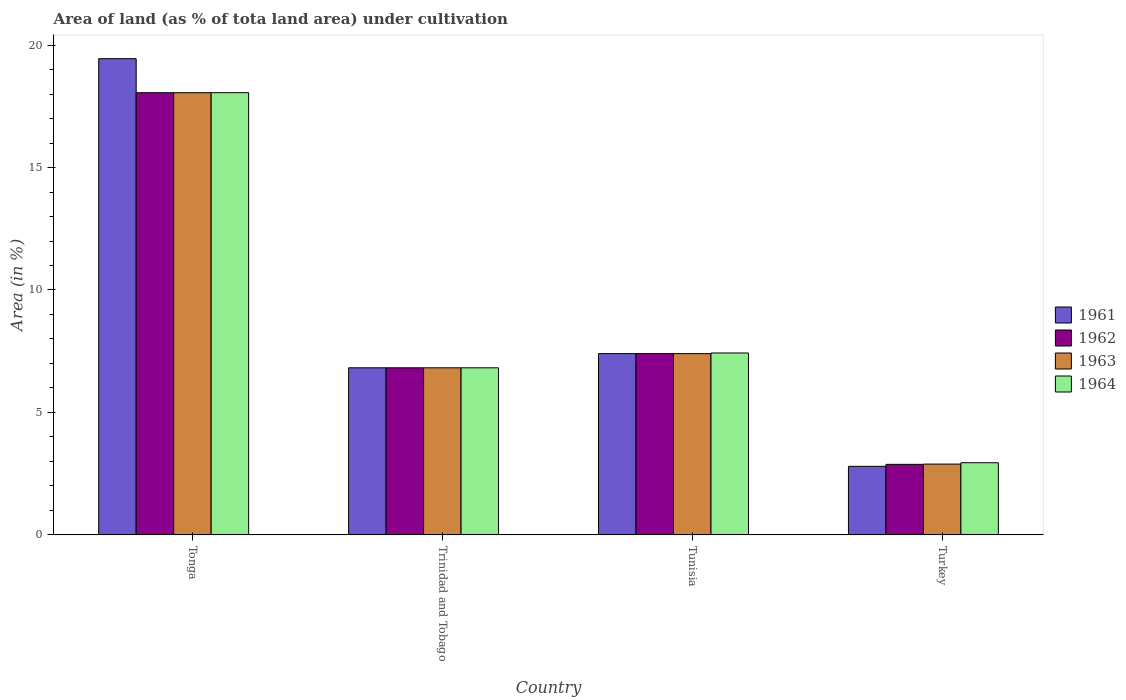Are the number of bars on each tick of the X-axis equal?
Your response must be concise. Yes. How many bars are there on the 3rd tick from the right?
Offer a very short reply. 4. What is the label of the 3rd group of bars from the left?
Provide a succinct answer. Tunisia. In how many cases, is the number of bars for a given country not equal to the number of legend labels?
Offer a very short reply. 0. What is the percentage of land under cultivation in 1961 in Tonga?
Offer a very short reply. 19.44. Across all countries, what is the maximum percentage of land under cultivation in 1962?
Provide a short and direct response. 18.06. Across all countries, what is the minimum percentage of land under cultivation in 1962?
Give a very brief answer. 2.88. In which country was the percentage of land under cultivation in 1964 maximum?
Your response must be concise. Tonga. In which country was the percentage of land under cultivation in 1964 minimum?
Make the answer very short. Turkey. What is the total percentage of land under cultivation in 1961 in the graph?
Your answer should be very brief. 36.47. What is the difference between the percentage of land under cultivation in 1961 in Tonga and that in Tunisia?
Your answer should be very brief. 12.04. What is the difference between the percentage of land under cultivation in 1963 in Trinidad and Tobago and the percentage of land under cultivation in 1964 in Turkey?
Keep it short and to the point. 3.88. What is the average percentage of land under cultivation in 1964 per country?
Keep it short and to the point. 8.81. What is the difference between the percentage of land under cultivation of/in 1963 and percentage of land under cultivation of/in 1961 in Tunisia?
Provide a succinct answer. 0. What is the ratio of the percentage of land under cultivation in 1963 in Tonga to that in Turkey?
Ensure brevity in your answer.  6.25. Is the percentage of land under cultivation in 1964 in Tunisia less than that in Turkey?
Provide a short and direct response. No. Is the difference between the percentage of land under cultivation in 1963 in Tonga and Trinidad and Tobago greater than the difference between the percentage of land under cultivation in 1961 in Tonga and Trinidad and Tobago?
Your answer should be very brief. No. What is the difference between the highest and the second highest percentage of land under cultivation in 1962?
Your answer should be very brief. 11.23. What is the difference between the highest and the lowest percentage of land under cultivation in 1961?
Offer a terse response. 16.65. Is the sum of the percentage of land under cultivation in 1963 in Trinidad and Tobago and Turkey greater than the maximum percentage of land under cultivation in 1962 across all countries?
Provide a succinct answer. No. Is it the case that in every country, the sum of the percentage of land under cultivation in 1962 and percentage of land under cultivation in 1963 is greater than the sum of percentage of land under cultivation in 1961 and percentage of land under cultivation in 1964?
Offer a terse response. No. What does the 1st bar from the left in Trinidad and Tobago represents?
Offer a very short reply. 1961. What does the 1st bar from the right in Turkey represents?
Offer a very short reply. 1964. What is the difference between two consecutive major ticks on the Y-axis?
Your response must be concise. 5. Are the values on the major ticks of Y-axis written in scientific E-notation?
Make the answer very short. No. How are the legend labels stacked?
Offer a very short reply. Vertical. What is the title of the graph?
Your response must be concise. Area of land (as % of tota land area) under cultivation. What is the label or title of the Y-axis?
Ensure brevity in your answer.  Area (in %). What is the Area (in %) in 1961 in Tonga?
Offer a terse response. 19.44. What is the Area (in %) of 1962 in Tonga?
Ensure brevity in your answer.  18.06. What is the Area (in %) in 1963 in Tonga?
Keep it short and to the point. 18.06. What is the Area (in %) of 1964 in Tonga?
Keep it short and to the point. 18.06. What is the Area (in %) of 1961 in Trinidad and Tobago?
Provide a short and direct response. 6.82. What is the Area (in %) of 1962 in Trinidad and Tobago?
Your answer should be compact. 6.82. What is the Area (in %) of 1963 in Trinidad and Tobago?
Your answer should be compact. 6.82. What is the Area (in %) in 1964 in Trinidad and Tobago?
Offer a very short reply. 6.82. What is the Area (in %) in 1961 in Tunisia?
Your answer should be very brief. 7.4. What is the Area (in %) in 1962 in Tunisia?
Your answer should be compact. 7.4. What is the Area (in %) in 1963 in Tunisia?
Make the answer very short. 7.4. What is the Area (in %) of 1964 in Tunisia?
Offer a terse response. 7.43. What is the Area (in %) in 1961 in Turkey?
Your answer should be compact. 2.8. What is the Area (in %) of 1962 in Turkey?
Keep it short and to the point. 2.88. What is the Area (in %) in 1963 in Turkey?
Provide a succinct answer. 2.89. What is the Area (in %) of 1964 in Turkey?
Offer a very short reply. 2.95. Across all countries, what is the maximum Area (in %) of 1961?
Give a very brief answer. 19.44. Across all countries, what is the maximum Area (in %) in 1962?
Your response must be concise. 18.06. Across all countries, what is the maximum Area (in %) in 1963?
Make the answer very short. 18.06. Across all countries, what is the maximum Area (in %) of 1964?
Give a very brief answer. 18.06. Across all countries, what is the minimum Area (in %) in 1961?
Offer a terse response. 2.8. Across all countries, what is the minimum Area (in %) in 1962?
Your response must be concise. 2.88. Across all countries, what is the minimum Area (in %) in 1963?
Give a very brief answer. 2.89. Across all countries, what is the minimum Area (in %) in 1964?
Your answer should be very brief. 2.95. What is the total Area (in %) of 1961 in the graph?
Offer a very short reply. 36.47. What is the total Area (in %) of 1962 in the graph?
Ensure brevity in your answer.  35.16. What is the total Area (in %) of 1963 in the graph?
Give a very brief answer. 35.17. What is the total Area (in %) in 1964 in the graph?
Your answer should be compact. 35.25. What is the difference between the Area (in %) in 1961 in Tonga and that in Trinidad and Tobago?
Your answer should be compact. 12.62. What is the difference between the Area (in %) in 1962 in Tonga and that in Trinidad and Tobago?
Provide a short and direct response. 11.23. What is the difference between the Area (in %) of 1963 in Tonga and that in Trinidad and Tobago?
Offer a very short reply. 11.23. What is the difference between the Area (in %) in 1964 in Tonga and that in Trinidad and Tobago?
Provide a succinct answer. 11.23. What is the difference between the Area (in %) in 1961 in Tonga and that in Tunisia?
Ensure brevity in your answer.  12.04. What is the difference between the Area (in %) of 1962 in Tonga and that in Tunisia?
Keep it short and to the point. 10.65. What is the difference between the Area (in %) of 1963 in Tonga and that in Tunisia?
Make the answer very short. 10.65. What is the difference between the Area (in %) in 1964 in Tonga and that in Tunisia?
Your answer should be very brief. 10.63. What is the difference between the Area (in %) of 1961 in Tonga and that in Turkey?
Offer a very short reply. 16.65. What is the difference between the Area (in %) in 1962 in Tonga and that in Turkey?
Your answer should be compact. 15.18. What is the difference between the Area (in %) of 1963 in Tonga and that in Turkey?
Give a very brief answer. 15.16. What is the difference between the Area (in %) of 1964 in Tonga and that in Turkey?
Your answer should be very brief. 15.11. What is the difference between the Area (in %) of 1961 in Trinidad and Tobago and that in Tunisia?
Your answer should be very brief. -0.58. What is the difference between the Area (in %) of 1962 in Trinidad and Tobago and that in Tunisia?
Ensure brevity in your answer.  -0.58. What is the difference between the Area (in %) in 1963 in Trinidad and Tobago and that in Tunisia?
Your answer should be compact. -0.58. What is the difference between the Area (in %) in 1964 in Trinidad and Tobago and that in Tunisia?
Ensure brevity in your answer.  -0.61. What is the difference between the Area (in %) of 1961 in Trinidad and Tobago and that in Turkey?
Give a very brief answer. 4.02. What is the difference between the Area (in %) of 1962 in Trinidad and Tobago and that in Turkey?
Provide a short and direct response. 3.94. What is the difference between the Area (in %) in 1963 in Trinidad and Tobago and that in Turkey?
Give a very brief answer. 3.93. What is the difference between the Area (in %) in 1964 in Trinidad and Tobago and that in Turkey?
Ensure brevity in your answer.  3.88. What is the difference between the Area (in %) in 1961 in Tunisia and that in Turkey?
Provide a succinct answer. 4.6. What is the difference between the Area (in %) in 1962 in Tunisia and that in Turkey?
Keep it short and to the point. 4.52. What is the difference between the Area (in %) in 1963 in Tunisia and that in Turkey?
Your answer should be very brief. 4.51. What is the difference between the Area (in %) of 1964 in Tunisia and that in Turkey?
Provide a short and direct response. 4.48. What is the difference between the Area (in %) of 1961 in Tonga and the Area (in %) of 1962 in Trinidad and Tobago?
Offer a terse response. 12.62. What is the difference between the Area (in %) of 1961 in Tonga and the Area (in %) of 1963 in Trinidad and Tobago?
Offer a terse response. 12.62. What is the difference between the Area (in %) in 1961 in Tonga and the Area (in %) in 1964 in Trinidad and Tobago?
Keep it short and to the point. 12.62. What is the difference between the Area (in %) in 1962 in Tonga and the Area (in %) in 1963 in Trinidad and Tobago?
Your answer should be very brief. 11.23. What is the difference between the Area (in %) in 1962 in Tonga and the Area (in %) in 1964 in Trinidad and Tobago?
Provide a short and direct response. 11.23. What is the difference between the Area (in %) in 1963 in Tonga and the Area (in %) in 1964 in Trinidad and Tobago?
Your answer should be very brief. 11.23. What is the difference between the Area (in %) in 1961 in Tonga and the Area (in %) in 1962 in Tunisia?
Offer a terse response. 12.04. What is the difference between the Area (in %) in 1961 in Tonga and the Area (in %) in 1963 in Tunisia?
Make the answer very short. 12.04. What is the difference between the Area (in %) of 1961 in Tonga and the Area (in %) of 1964 in Tunisia?
Provide a short and direct response. 12.02. What is the difference between the Area (in %) in 1962 in Tonga and the Area (in %) in 1963 in Tunisia?
Offer a very short reply. 10.65. What is the difference between the Area (in %) in 1962 in Tonga and the Area (in %) in 1964 in Tunisia?
Make the answer very short. 10.63. What is the difference between the Area (in %) in 1963 in Tonga and the Area (in %) in 1964 in Tunisia?
Give a very brief answer. 10.63. What is the difference between the Area (in %) in 1961 in Tonga and the Area (in %) in 1962 in Turkey?
Your answer should be very brief. 16.56. What is the difference between the Area (in %) of 1961 in Tonga and the Area (in %) of 1963 in Turkey?
Ensure brevity in your answer.  16.55. What is the difference between the Area (in %) in 1961 in Tonga and the Area (in %) in 1964 in Turkey?
Provide a succinct answer. 16.5. What is the difference between the Area (in %) in 1962 in Tonga and the Area (in %) in 1963 in Turkey?
Your answer should be compact. 15.16. What is the difference between the Area (in %) in 1962 in Tonga and the Area (in %) in 1964 in Turkey?
Keep it short and to the point. 15.11. What is the difference between the Area (in %) in 1963 in Tonga and the Area (in %) in 1964 in Turkey?
Provide a succinct answer. 15.11. What is the difference between the Area (in %) in 1961 in Trinidad and Tobago and the Area (in %) in 1962 in Tunisia?
Offer a terse response. -0.58. What is the difference between the Area (in %) in 1961 in Trinidad and Tobago and the Area (in %) in 1963 in Tunisia?
Offer a very short reply. -0.58. What is the difference between the Area (in %) of 1961 in Trinidad and Tobago and the Area (in %) of 1964 in Tunisia?
Your answer should be very brief. -0.61. What is the difference between the Area (in %) in 1962 in Trinidad and Tobago and the Area (in %) in 1963 in Tunisia?
Your answer should be compact. -0.58. What is the difference between the Area (in %) of 1962 in Trinidad and Tobago and the Area (in %) of 1964 in Tunisia?
Give a very brief answer. -0.61. What is the difference between the Area (in %) in 1963 in Trinidad and Tobago and the Area (in %) in 1964 in Tunisia?
Keep it short and to the point. -0.61. What is the difference between the Area (in %) in 1961 in Trinidad and Tobago and the Area (in %) in 1962 in Turkey?
Your answer should be compact. 3.94. What is the difference between the Area (in %) of 1961 in Trinidad and Tobago and the Area (in %) of 1963 in Turkey?
Make the answer very short. 3.93. What is the difference between the Area (in %) in 1961 in Trinidad and Tobago and the Area (in %) in 1964 in Turkey?
Provide a succinct answer. 3.88. What is the difference between the Area (in %) in 1962 in Trinidad and Tobago and the Area (in %) in 1963 in Turkey?
Your answer should be compact. 3.93. What is the difference between the Area (in %) of 1962 in Trinidad and Tobago and the Area (in %) of 1964 in Turkey?
Your answer should be compact. 3.88. What is the difference between the Area (in %) of 1963 in Trinidad and Tobago and the Area (in %) of 1964 in Turkey?
Offer a terse response. 3.88. What is the difference between the Area (in %) in 1961 in Tunisia and the Area (in %) in 1962 in Turkey?
Provide a succinct answer. 4.52. What is the difference between the Area (in %) of 1961 in Tunisia and the Area (in %) of 1963 in Turkey?
Give a very brief answer. 4.51. What is the difference between the Area (in %) of 1961 in Tunisia and the Area (in %) of 1964 in Turkey?
Offer a very short reply. 4.46. What is the difference between the Area (in %) in 1962 in Tunisia and the Area (in %) in 1963 in Turkey?
Offer a terse response. 4.51. What is the difference between the Area (in %) of 1962 in Tunisia and the Area (in %) of 1964 in Turkey?
Your answer should be very brief. 4.46. What is the difference between the Area (in %) of 1963 in Tunisia and the Area (in %) of 1964 in Turkey?
Make the answer very short. 4.46. What is the average Area (in %) in 1961 per country?
Provide a short and direct response. 9.12. What is the average Area (in %) of 1962 per country?
Provide a short and direct response. 8.79. What is the average Area (in %) in 1963 per country?
Make the answer very short. 8.79. What is the average Area (in %) of 1964 per country?
Offer a terse response. 8.81. What is the difference between the Area (in %) of 1961 and Area (in %) of 1962 in Tonga?
Keep it short and to the point. 1.39. What is the difference between the Area (in %) of 1961 and Area (in %) of 1963 in Tonga?
Your response must be concise. 1.39. What is the difference between the Area (in %) of 1961 and Area (in %) of 1964 in Tonga?
Your answer should be very brief. 1.39. What is the difference between the Area (in %) of 1962 and Area (in %) of 1964 in Tonga?
Make the answer very short. 0. What is the difference between the Area (in %) in 1963 and Area (in %) in 1964 in Tonga?
Provide a short and direct response. 0. What is the difference between the Area (in %) in 1961 and Area (in %) in 1962 in Trinidad and Tobago?
Your answer should be very brief. 0. What is the difference between the Area (in %) in 1961 and Area (in %) in 1963 in Trinidad and Tobago?
Make the answer very short. 0. What is the difference between the Area (in %) in 1961 and Area (in %) in 1964 in Trinidad and Tobago?
Ensure brevity in your answer.  0. What is the difference between the Area (in %) of 1962 and Area (in %) of 1963 in Trinidad and Tobago?
Offer a very short reply. 0. What is the difference between the Area (in %) in 1962 and Area (in %) in 1964 in Trinidad and Tobago?
Provide a short and direct response. 0. What is the difference between the Area (in %) in 1961 and Area (in %) in 1963 in Tunisia?
Your answer should be compact. 0. What is the difference between the Area (in %) of 1961 and Area (in %) of 1964 in Tunisia?
Your response must be concise. -0.03. What is the difference between the Area (in %) of 1962 and Area (in %) of 1963 in Tunisia?
Your answer should be compact. 0. What is the difference between the Area (in %) of 1962 and Area (in %) of 1964 in Tunisia?
Keep it short and to the point. -0.03. What is the difference between the Area (in %) in 1963 and Area (in %) in 1964 in Tunisia?
Provide a short and direct response. -0.03. What is the difference between the Area (in %) in 1961 and Area (in %) in 1962 in Turkey?
Provide a short and direct response. -0.08. What is the difference between the Area (in %) of 1961 and Area (in %) of 1963 in Turkey?
Keep it short and to the point. -0.09. What is the difference between the Area (in %) in 1961 and Area (in %) in 1964 in Turkey?
Offer a very short reply. -0.15. What is the difference between the Area (in %) in 1962 and Area (in %) in 1963 in Turkey?
Your response must be concise. -0.01. What is the difference between the Area (in %) in 1962 and Area (in %) in 1964 in Turkey?
Your response must be concise. -0.07. What is the difference between the Area (in %) of 1963 and Area (in %) of 1964 in Turkey?
Give a very brief answer. -0.06. What is the ratio of the Area (in %) of 1961 in Tonga to that in Trinidad and Tobago?
Ensure brevity in your answer.  2.85. What is the ratio of the Area (in %) in 1962 in Tonga to that in Trinidad and Tobago?
Offer a terse response. 2.65. What is the ratio of the Area (in %) of 1963 in Tonga to that in Trinidad and Tobago?
Keep it short and to the point. 2.65. What is the ratio of the Area (in %) of 1964 in Tonga to that in Trinidad and Tobago?
Your answer should be compact. 2.65. What is the ratio of the Area (in %) of 1961 in Tonga to that in Tunisia?
Ensure brevity in your answer.  2.63. What is the ratio of the Area (in %) in 1962 in Tonga to that in Tunisia?
Your response must be concise. 2.44. What is the ratio of the Area (in %) of 1963 in Tonga to that in Tunisia?
Provide a short and direct response. 2.44. What is the ratio of the Area (in %) of 1964 in Tonga to that in Tunisia?
Your response must be concise. 2.43. What is the ratio of the Area (in %) in 1961 in Tonga to that in Turkey?
Give a very brief answer. 6.95. What is the ratio of the Area (in %) of 1962 in Tonga to that in Turkey?
Ensure brevity in your answer.  6.27. What is the ratio of the Area (in %) of 1963 in Tonga to that in Turkey?
Provide a short and direct response. 6.25. What is the ratio of the Area (in %) of 1964 in Tonga to that in Turkey?
Provide a short and direct response. 6.13. What is the ratio of the Area (in %) in 1961 in Trinidad and Tobago to that in Tunisia?
Make the answer very short. 0.92. What is the ratio of the Area (in %) of 1962 in Trinidad and Tobago to that in Tunisia?
Offer a very short reply. 0.92. What is the ratio of the Area (in %) in 1963 in Trinidad and Tobago to that in Tunisia?
Give a very brief answer. 0.92. What is the ratio of the Area (in %) of 1964 in Trinidad and Tobago to that in Tunisia?
Make the answer very short. 0.92. What is the ratio of the Area (in %) in 1961 in Trinidad and Tobago to that in Turkey?
Your answer should be very brief. 2.44. What is the ratio of the Area (in %) of 1962 in Trinidad and Tobago to that in Turkey?
Your answer should be compact. 2.37. What is the ratio of the Area (in %) of 1963 in Trinidad and Tobago to that in Turkey?
Offer a very short reply. 2.36. What is the ratio of the Area (in %) of 1964 in Trinidad and Tobago to that in Turkey?
Offer a terse response. 2.32. What is the ratio of the Area (in %) of 1961 in Tunisia to that in Turkey?
Your answer should be compact. 2.64. What is the ratio of the Area (in %) of 1962 in Tunisia to that in Turkey?
Ensure brevity in your answer.  2.57. What is the ratio of the Area (in %) of 1963 in Tunisia to that in Turkey?
Offer a terse response. 2.56. What is the ratio of the Area (in %) in 1964 in Tunisia to that in Turkey?
Provide a short and direct response. 2.52. What is the difference between the highest and the second highest Area (in %) of 1961?
Your answer should be very brief. 12.04. What is the difference between the highest and the second highest Area (in %) of 1962?
Provide a succinct answer. 10.65. What is the difference between the highest and the second highest Area (in %) in 1963?
Make the answer very short. 10.65. What is the difference between the highest and the second highest Area (in %) in 1964?
Offer a very short reply. 10.63. What is the difference between the highest and the lowest Area (in %) of 1961?
Make the answer very short. 16.65. What is the difference between the highest and the lowest Area (in %) of 1962?
Make the answer very short. 15.18. What is the difference between the highest and the lowest Area (in %) in 1963?
Keep it short and to the point. 15.16. What is the difference between the highest and the lowest Area (in %) of 1964?
Your response must be concise. 15.11. 